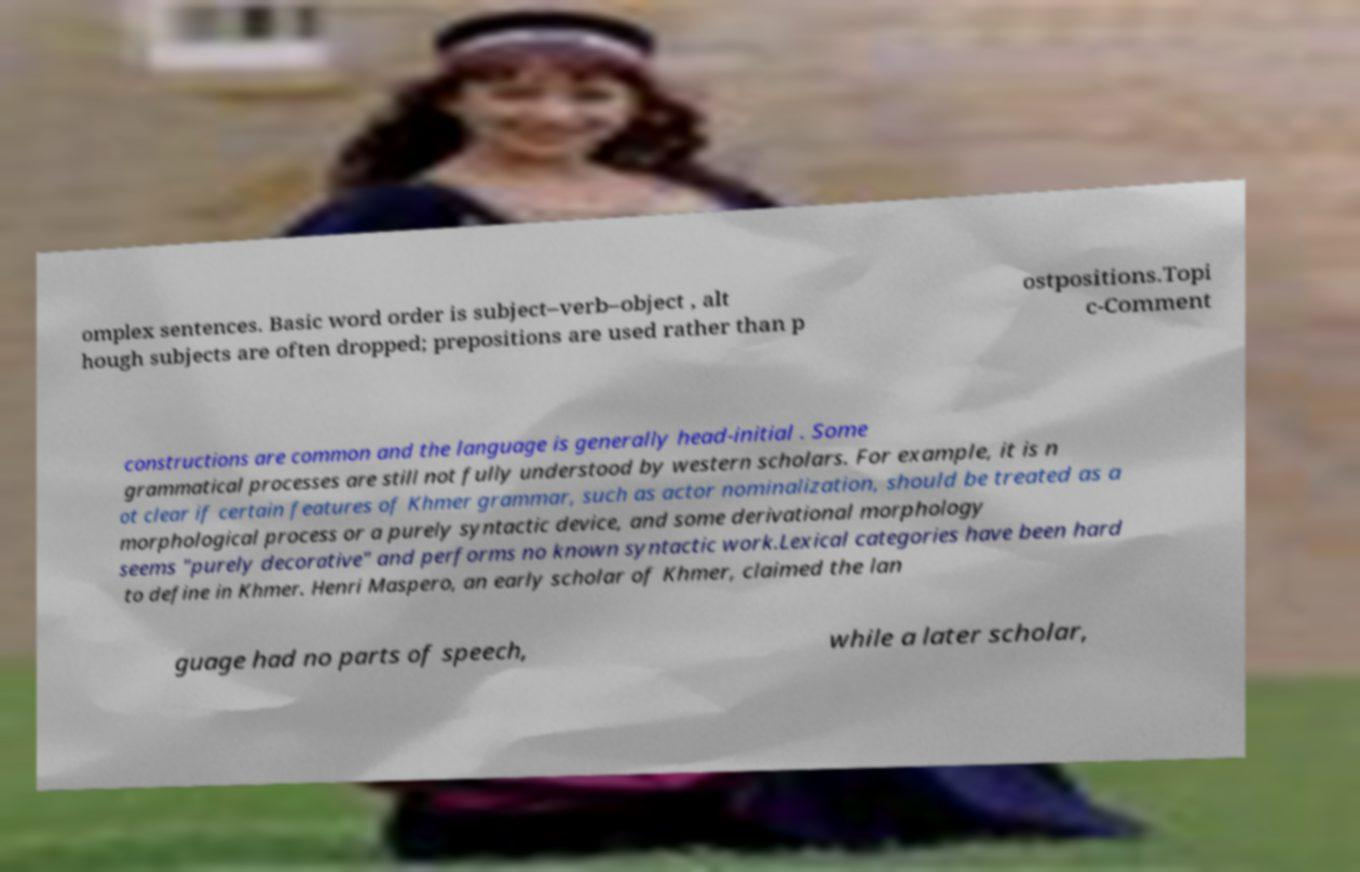Could you assist in decoding the text presented in this image and type it out clearly? omplex sentences. Basic word order is subject–verb–object , alt hough subjects are often dropped; prepositions are used rather than p ostpositions.Topi c-Comment constructions are common and the language is generally head-initial . Some grammatical processes are still not fully understood by western scholars. For example, it is n ot clear if certain features of Khmer grammar, such as actor nominalization, should be treated as a morphological process or a purely syntactic device, and some derivational morphology seems "purely decorative" and performs no known syntactic work.Lexical categories have been hard to define in Khmer. Henri Maspero, an early scholar of Khmer, claimed the lan guage had no parts of speech, while a later scholar, 